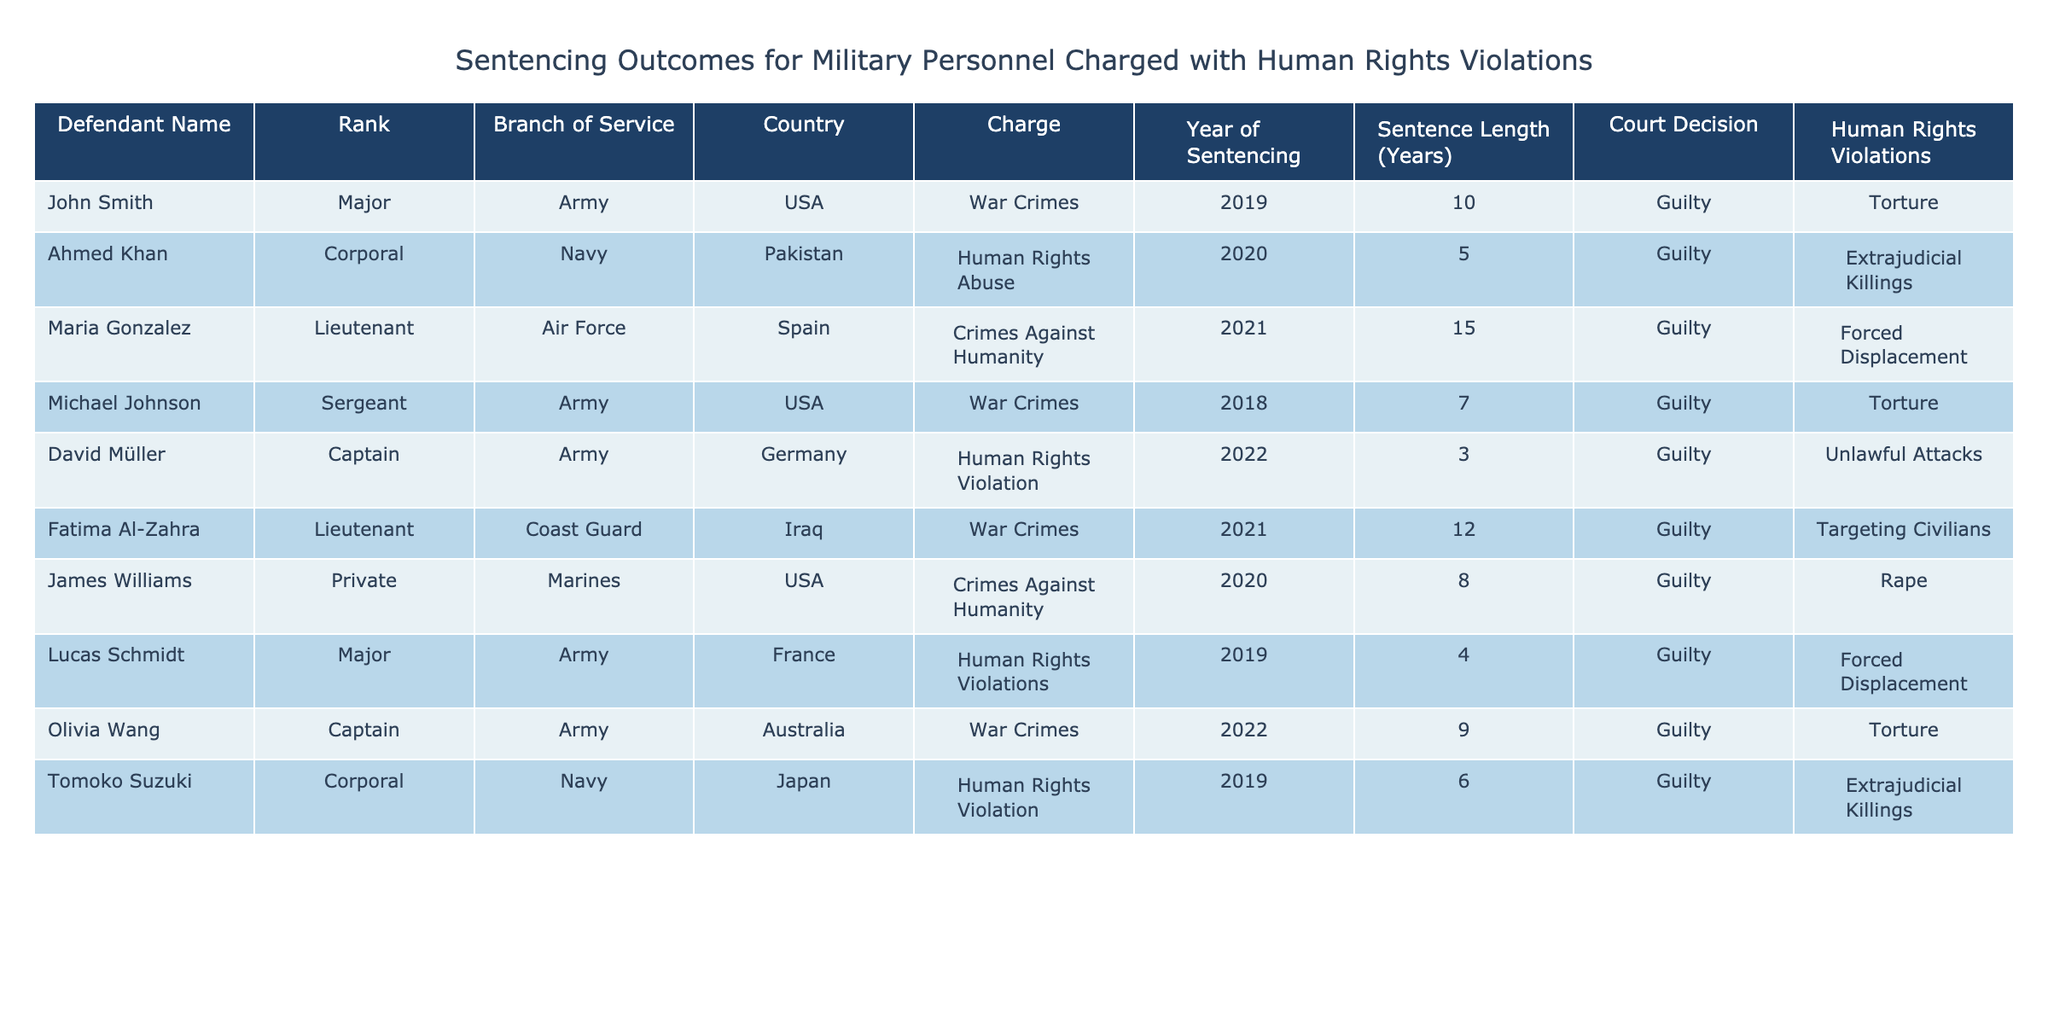What is the longest sentence length given in the table? The table lists the sentence lengths for various defendants, and by scanning the "Sentence Length (Years)" column, we can identify that the maximum value is 15 years for Maria Gonzalez.
Answer: 15 How many defendants were charged with War Crimes? By counting the entries in the "Charge" column that state "War Crimes," we find three defendants: John Smith, Fatima Al-Zahra, and Olivia Wang.
Answer: 3 Which country had the defendant with the shortest sentence? Reviewing the "Country" and "Sentence Length (Years)" columns, the defendant with the shortest sentence of 3 years is David Müller from Germany.
Answer: Germany Is there a defendant from the USA who was acquitted? By examining the "Court Decision" column for the USA defendants, all are guilty, indicating there are no acquittals.
Answer: No What is the average sentence length for all defendants charged with Crimes Against Humanity? The sentence lengths for defendants charged with Crimes Against Humanity are 15 years (Maria Gonzalez) and 8 years (James Williams). The average is (15 + 8) / 2 = 11.5 years.
Answer: 11.5 Which branch of service had the highest number of defendants? Scanning the "Branch of Service" column, the Army appears four times (John Smith, Michael Johnson, David Müller, Olivia Wang), more than any other branch.
Answer: Army How many defendants received sentences of 10 years or more? By reviewing the "Sentence Length (Years)" column, we find two defendants with sentences of 10 years or more: John Smith (10) and Maria Gonzalez (15).
Answer: 2 Are there any defendants from the Navy charged with Torture? By looking at the "Charge" column for any Navy defendants, we see that none are charged with Torture; the charges listed are Human Rights Abuse and Human Rights Violation.
Answer: No What percentage of the defendants were found guilty? All the defendants in the table are listed as guilty, totaling 10. Since 10 out of 10 results in 100%, the percentage is 100%.
Answer: 100% Which human rights violation is mentioned most frequently? By reviewing the "Human Rights Violations" column, "Torture" appears three times (John Smith, Michael Johnson, Olivia Wang), making it the most frequent violation.
Answer: Torture 